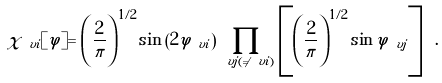Convert formula to latex. <formula><loc_0><loc_0><loc_500><loc_500>\chi _ { \ v i } [ \varphi ] = \left ( \frac { 2 } { \pi } \right ) ^ { 1 / 2 } \sin \left ( 2 \varphi _ { \ v i } \right ) \prod _ { \ v j ( \neq \ v i ) } \left [ \left ( \frac { 2 } { \pi } \right ) ^ { 1 / 2 } \sin \varphi _ { \ v j } \right ] \ .</formula> 